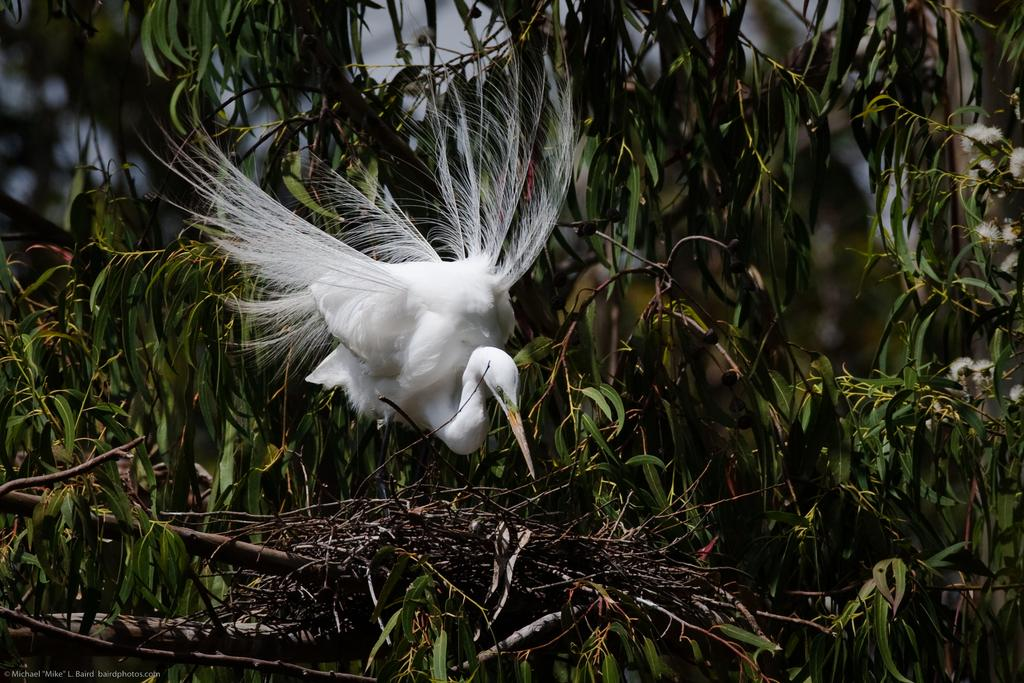What is the main subject of the image? The main subject of the image is a bird flying. What objects can be seen in the image besides the bird? There are sticks and green leaves visible in the image. What type of air can be seen in the image? There is no air visible in the image; it is the bird that is flying. Is there a crate present in the image? No, there is no crate present in the image. 